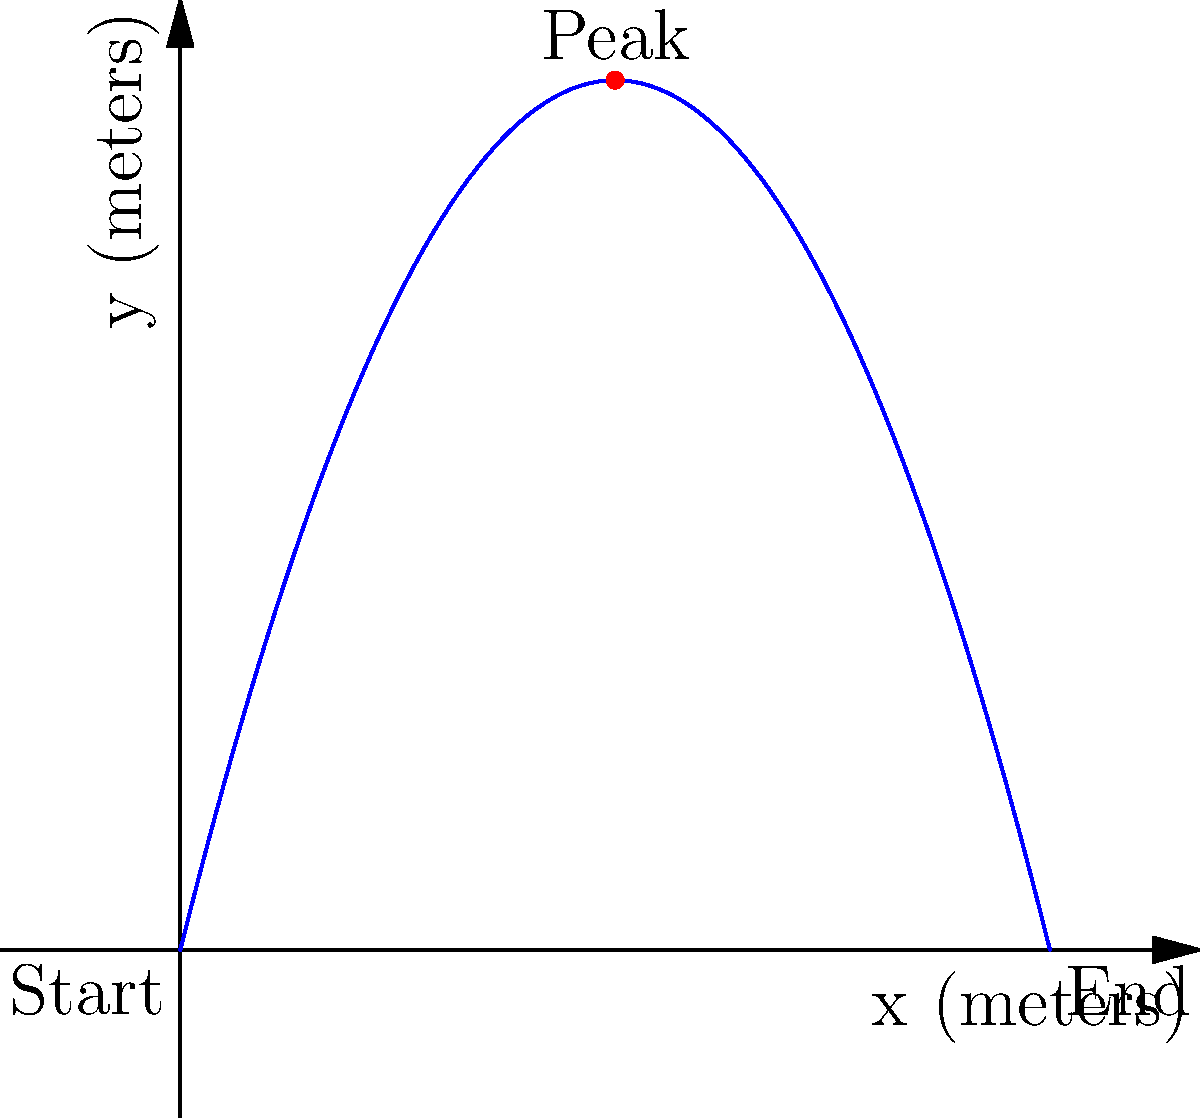In a performance of the Joffrey Ballet, a dancer performs a grand jeté leap. The trajectory of the leap can be modeled by the parabolic function $f(x) = -0.5x^2 + 4x$, where $x$ represents the horizontal distance traveled in meters, and $f(x)$ represents the height in meters. What is the total horizontal distance covered by the dancer during this leap? To find the total horizontal distance covered by the dancer, we need to determine the x-intercepts of the parabolic function, which represent the start and end points of the leap.

Step 1: Set up the equation $f(x) = 0$ to find the x-intercepts.
$-0.5x^2 + 4x = 0$

Step 2: Factor out the common factor x.
$x(-0.5x + 4) = 0$

Step 3: Solve the equation.
$x = 0$ or $-0.5x + 4 = 0$
$x = 0$ or $x = 8$

Step 4: Interpret the results.
The leap starts at $x = 0$ and ends at $x = 8$.

Step 5: Calculate the total horizontal distance.
Total distance = End point - Start point = $8 - 0 = 8$ meters
Answer: 8 meters 